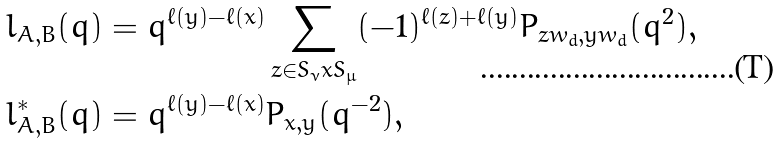<formula> <loc_0><loc_0><loc_500><loc_500>l _ { A , B } ( q ) & = q ^ { \ell ( y ) - \ell ( x ) } \sum _ { z \in S _ { \nu } x S _ { \mu } } ( - 1 ) ^ { \ell ( z ) + \ell ( y ) } P _ { z w _ { d } , y w _ { d } } ( q ^ { 2 } ) , \\ l ^ { * } _ { A , B } ( q ) & = q ^ { \ell ( y ) - \ell ( x ) } P _ { x , y } ( q ^ { - 2 } ) ,</formula> 